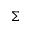Convert formula to latex. <formula><loc_0><loc_0><loc_500><loc_500>\Sigma</formula> 